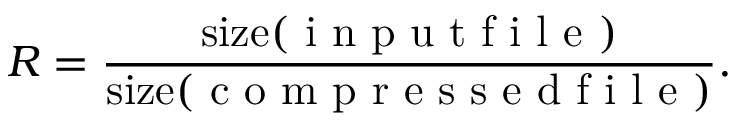Convert formula to latex. <formula><loc_0><loc_0><loc_500><loc_500>R = \frac { s i z e ( i n p u t f i l e ) } { s i z e ( c o m p r e s s e d f i l e ) } .</formula> 